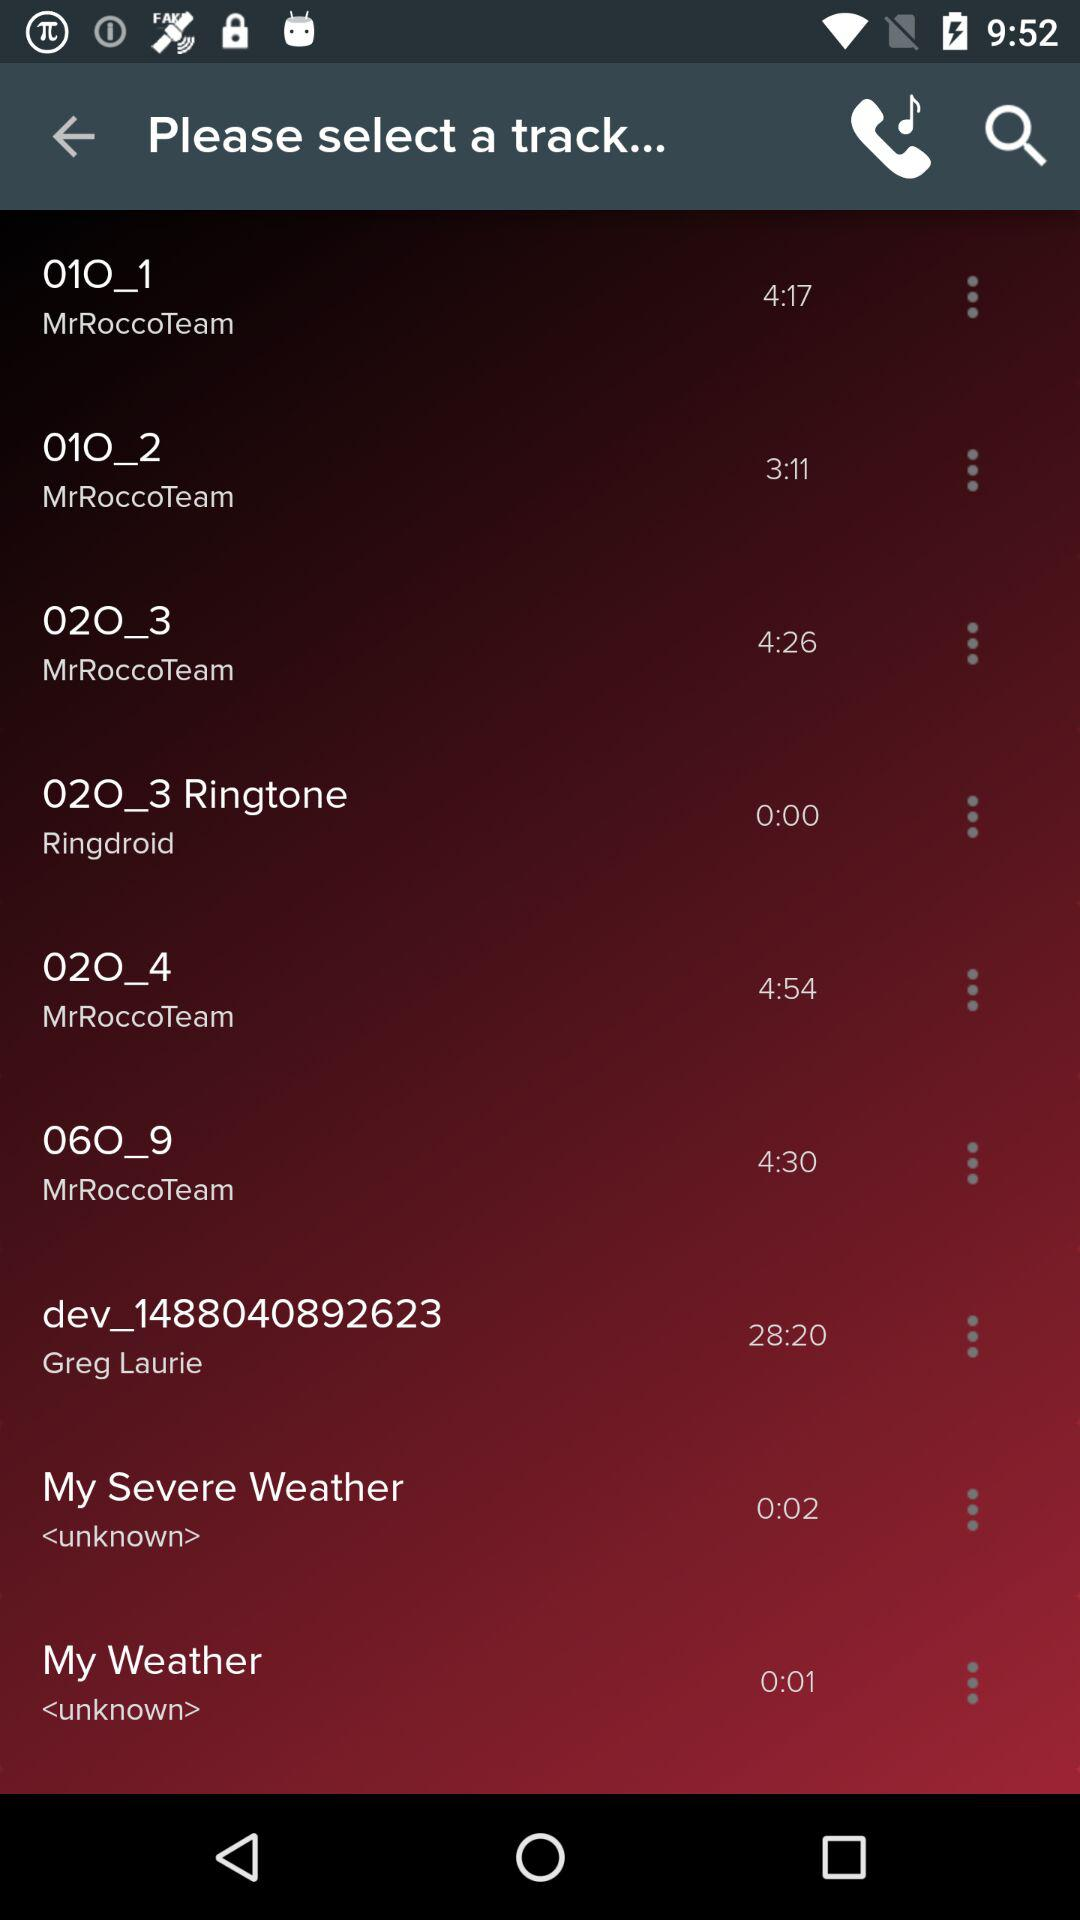What is the duration of "02O_4"? The duration of "02O_4" is 4 minutes 54 seconds. 